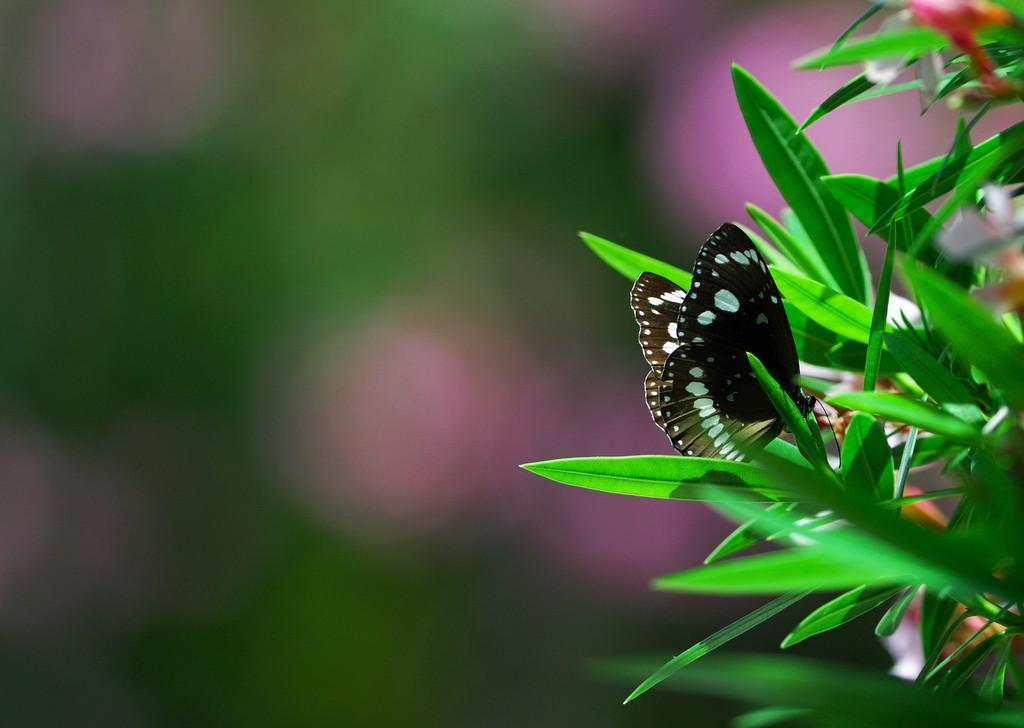What is the main subject in the image? There is a butterfly in the image. Where is the butterfly located? The butterfly is on a leaf. What type of trade is the butterfly involved in on the leaf? The butterfly is not involved in any trade; it is simply resting on the leaf. What type of bee can be seen interacting with the butterfly on the leaf? There is no bee present in the image; it only features a butterfly on a leaf. 